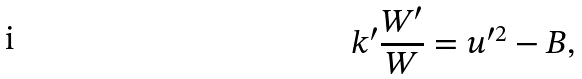Convert formula to latex. <formula><loc_0><loc_0><loc_500><loc_500>k ^ { \prime } \frac { W ^ { \prime } } W = u ^ { \prime 2 } - B ,</formula> 